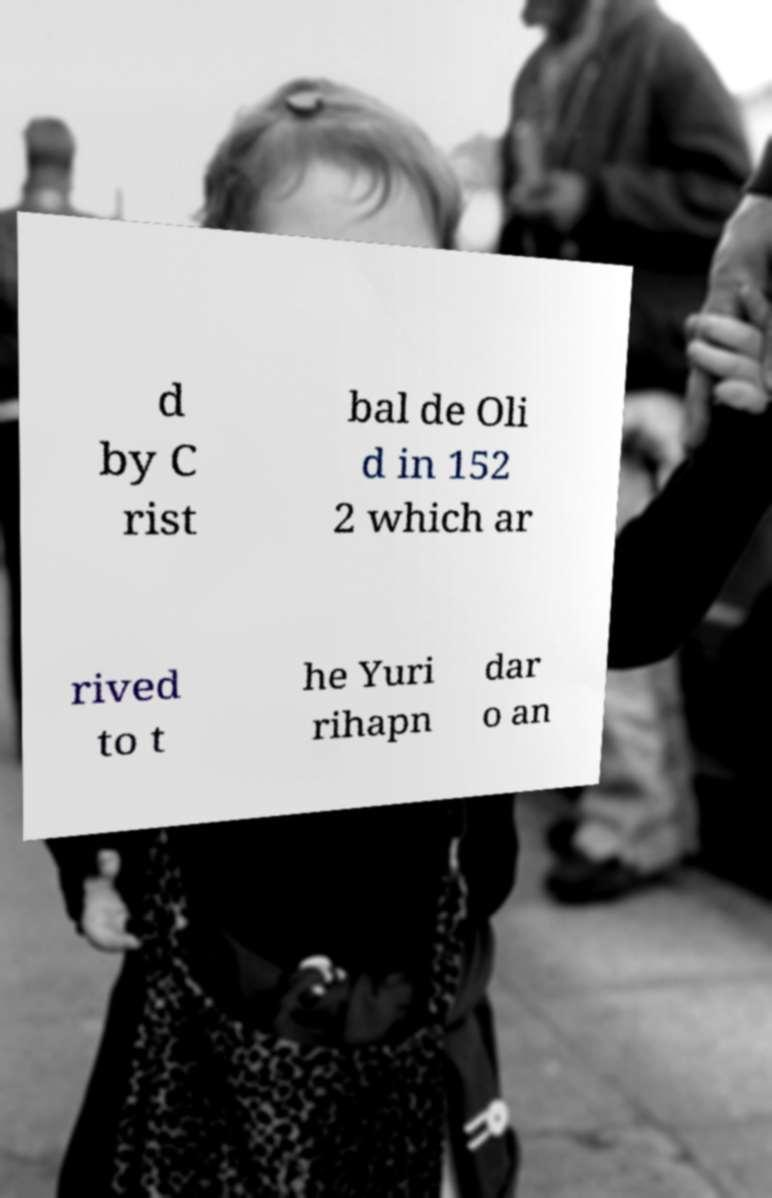Can you read and provide the text displayed in the image?This photo seems to have some interesting text. Can you extract and type it out for me? d by C rist bal de Oli d in 152 2 which ar rived to t he Yuri rihapn dar o an 